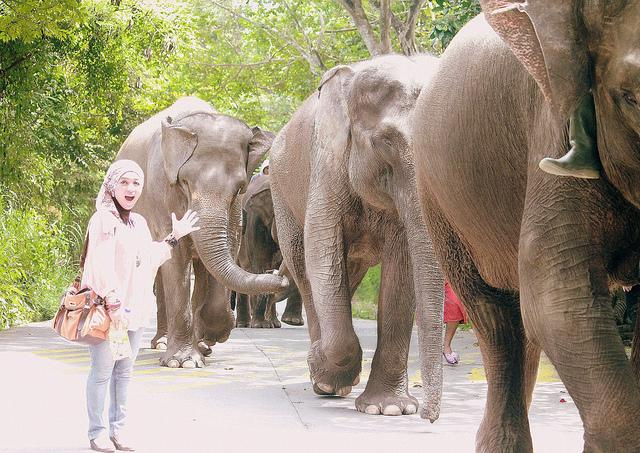What is the expression on the woman's face? Please explain your reasoning. excitement. The woman is very excited. 